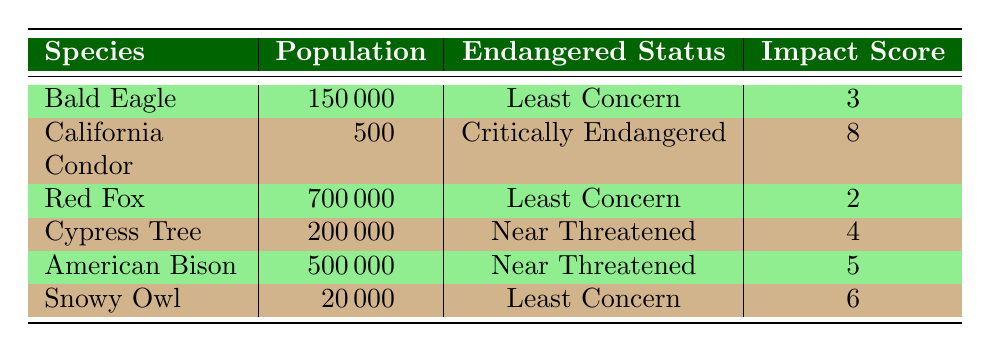What is the population estimate of the Snowy Owl? The table directly lists the population estimate for each species. For the Snowy Owl, it shows 20,000.
Answer: 20,000 How many species are classified as "Least Concern"? By scrutinizing the "Endangered Status" column, I note that both the Bald Eagle and Red Fox fall under "Least Concern." Therefore, there are three species listed in this category.
Answer: 3 Which species has the highest impact score, and what is that score? Looking through the table, the "Impact Score" for the California Condor is listed as 8, which is greater than any other species's score.
Answer: California Condor, 8 What is the average population estimate for species that are "Near Threatened"? The species listed as "Near Threatened" are the Cypress Tree and American Bison, with populations of 200,000 and 500,000, respectively. The average population is calculated as (200,000 + 500,000) / 2 = 350,000.
Answer: 350,000 Is the California Condor's population estimate higher than that of the Red Fox? The population of the California Condor is 500, while that of the Red Fox is 700,000. Since 500 is less than 700,000, the statement is false.
Answer: No 